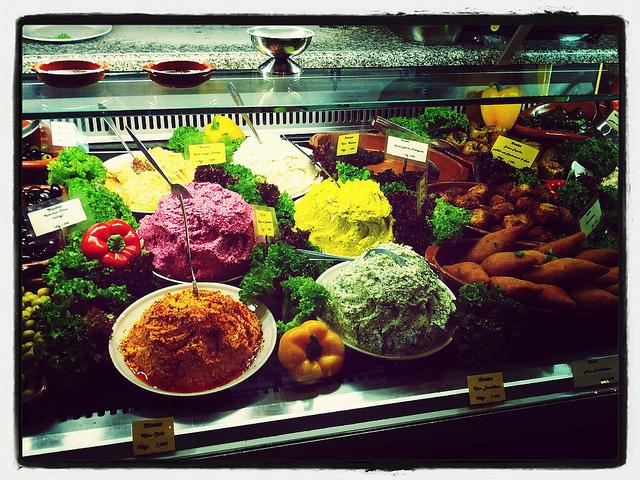What is between the camera and the yellow pepper?
Be succinct. Glass. Can I buy food here?
Concise answer only. Yes. What place is this?
Quick response, please. Deli. 